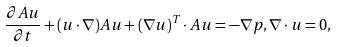<formula> <loc_0><loc_0><loc_500><loc_500>\frac { \partial A { u } } { \partial t } + ( { u } \cdot \nabla ) A { u } + ( \nabla { u } ) ^ { T } \cdot A { u } = - \nabla p , \nabla \cdot { u } = 0 ,</formula> 